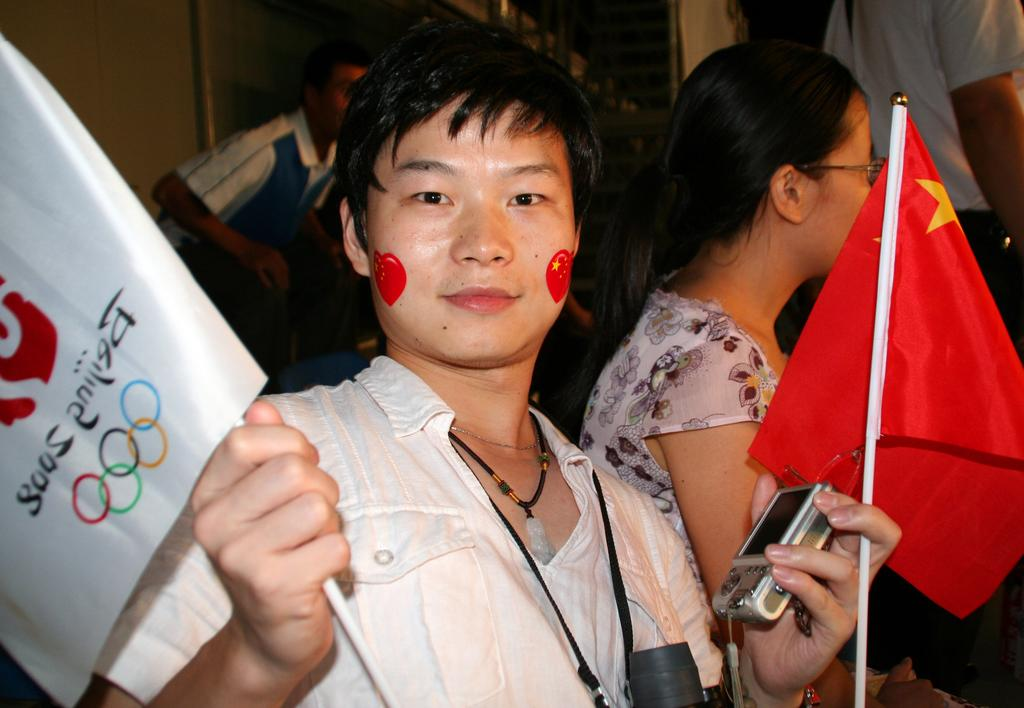Who is the main subject in the image? There is a man in the center of the image. What is the man holding in his hands? The man is holding two flags and a camera. Can you describe the background of the image? There are other persons visible in the background of the image. What type of fuel is the man using to power the camera in the image? There is no indication in the image that the man is using any fuel to power the camera. The camera is likely powered by batteries or electricity. 